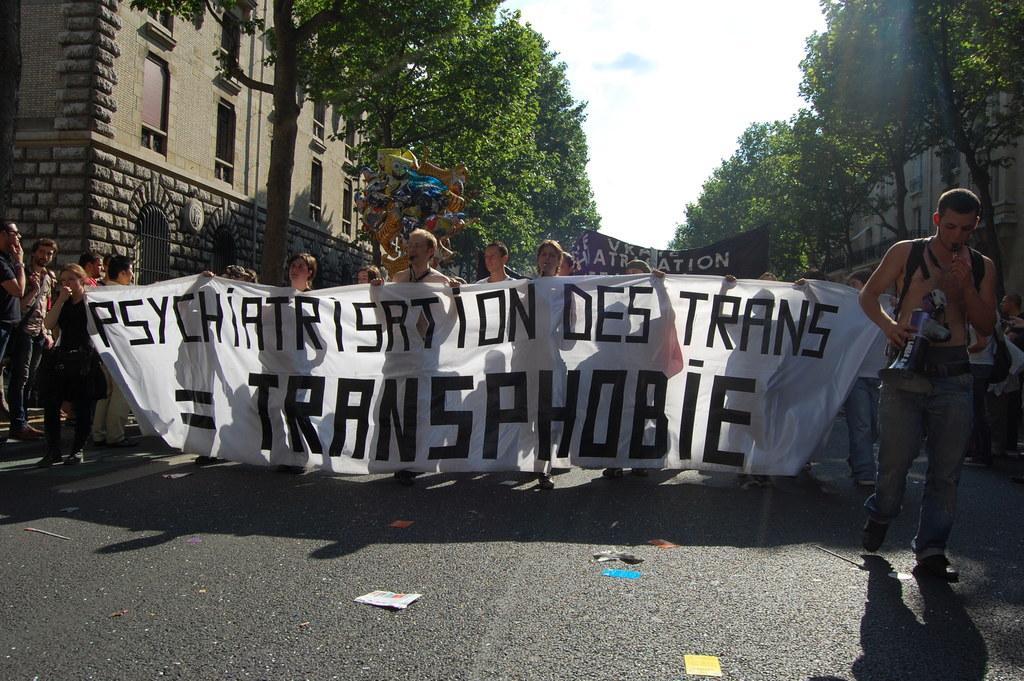Describe this image in one or two sentences. In this picture we can see a group of people, papers on the road, some people are holding banners, one person is holding a mic and in the background we can see buildings, trees, sky and some objects. 